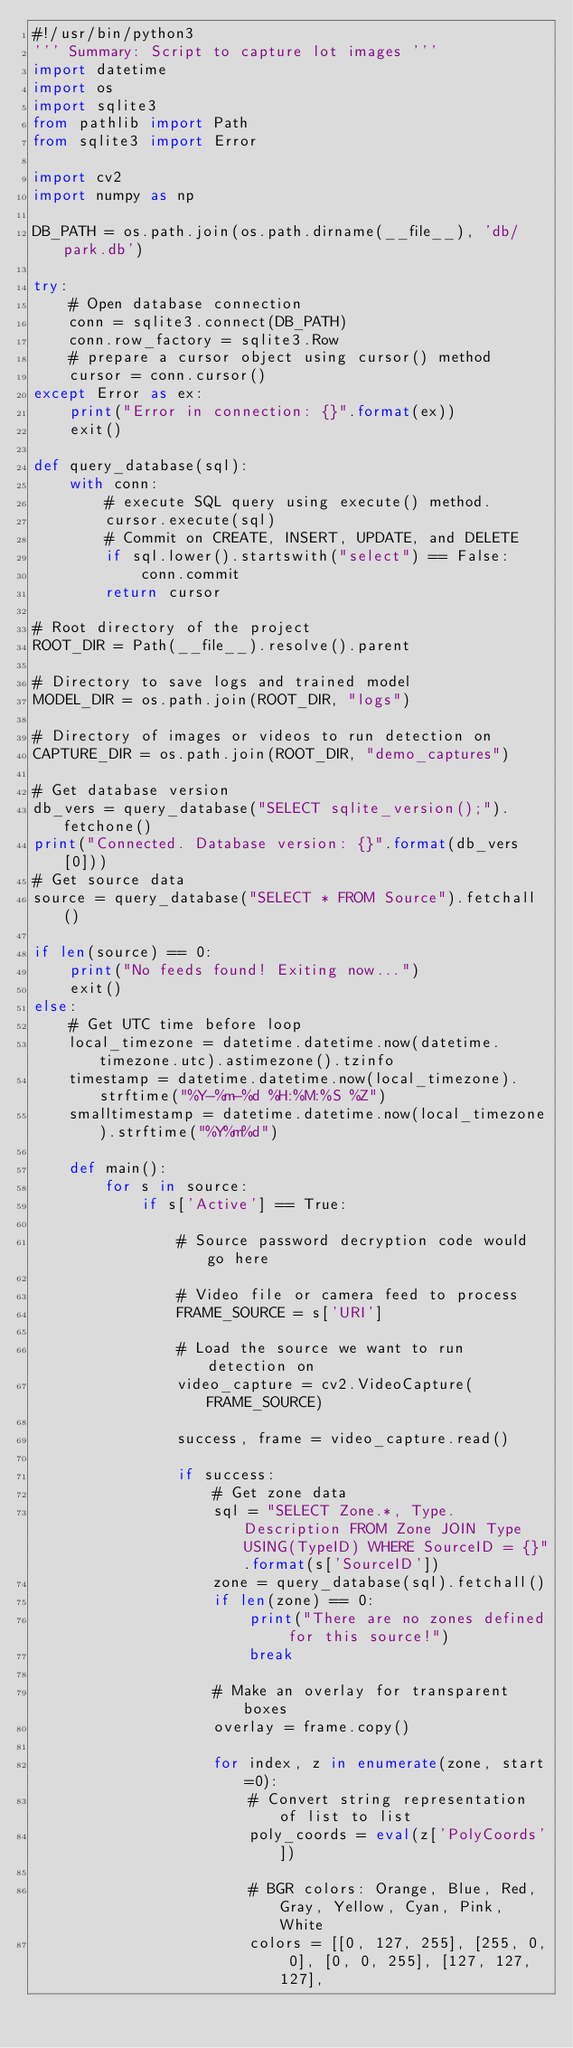Convert code to text. <code><loc_0><loc_0><loc_500><loc_500><_Python_>#!/usr/bin/python3
''' Summary: Script to capture lot images '''
import datetime
import os
import sqlite3
from pathlib import Path
from sqlite3 import Error

import cv2
import numpy as np

DB_PATH = os.path.join(os.path.dirname(__file__), 'db/park.db')

try:
    # Open database connection
    conn = sqlite3.connect(DB_PATH)
    conn.row_factory = sqlite3.Row
    # prepare a cursor object using cursor() method
    cursor = conn.cursor()
except Error as ex:
    print("Error in connection: {}".format(ex))
    exit()

def query_database(sql):
    with conn:
        # execute SQL query using execute() method.
        cursor.execute(sql)
        # Commit on CREATE, INSERT, UPDATE, and DELETE
        if sql.lower().startswith("select") == False:
            conn.commit
        return cursor

# Root directory of the project
ROOT_DIR = Path(__file__).resolve().parent

# Directory to save logs and trained model
MODEL_DIR = os.path.join(ROOT_DIR, "logs")

# Directory of images or videos to run detection on
CAPTURE_DIR = os.path.join(ROOT_DIR, "demo_captures")

# Get database version
db_vers = query_database("SELECT sqlite_version();").fetchone()
print("Connected. Database version: {}".format(db_vers[0]))
# Get source data
source = query_database("SELECT * FROM Source").fetchall()

if len(source) == 0:
    print("No feeds found! Exiting now...")
    exit()
else:
    # Get UTC time before loop
    local_timezone = datetime.datetime.now(datetime.timezone.utc).astimezone().tzinfo
    timestamp = datetime.datetime.now(local_timezone).strftime("%Y-%m-%d %H:%M:%S %Z")
    smalltimestamp = datetime.datetime.now(local_timezone).strftime("%Y%m%d")

    def main():
        for s in source:
            if s['Active'] == True:

                # Source password decryption code would go here

                # Video file or camera feed to process
                FRAME_SOURCE = s['URI']

                # Load the source we want to run detection on
                video_capture = cv2.VideoCapture(FRAME_SOURCE)

                success, frame = video_capture.read()

                if success:
                    # Get zone data
                    sql = "SELECT Zone.*, Type.Description FROM Zone JOIN Type USING(TypeID) WHERE SourceID = {}".format(s['SourceID'])
                    zone = query_database(sql).fetchall()
                    if len(zone) == 0:
                        print("There are no zones defined for this source!")
                        break

                    # Make an overlay for transparent boxes
                    overlay = frame.copy()

                    for index, z in enumerate(zone, start=0):
                        # Convert string representation of list to list
                        poly_coords = eval(z['PolyCoords'])

                        # BGR colors: Orange, Blue, Red, Gray, Yellow, Cyan, Pink, White
                        colors = [[0, 127, 255], [255, 0, 0], [0, 0, 255], [127, 127, 127],</code> 